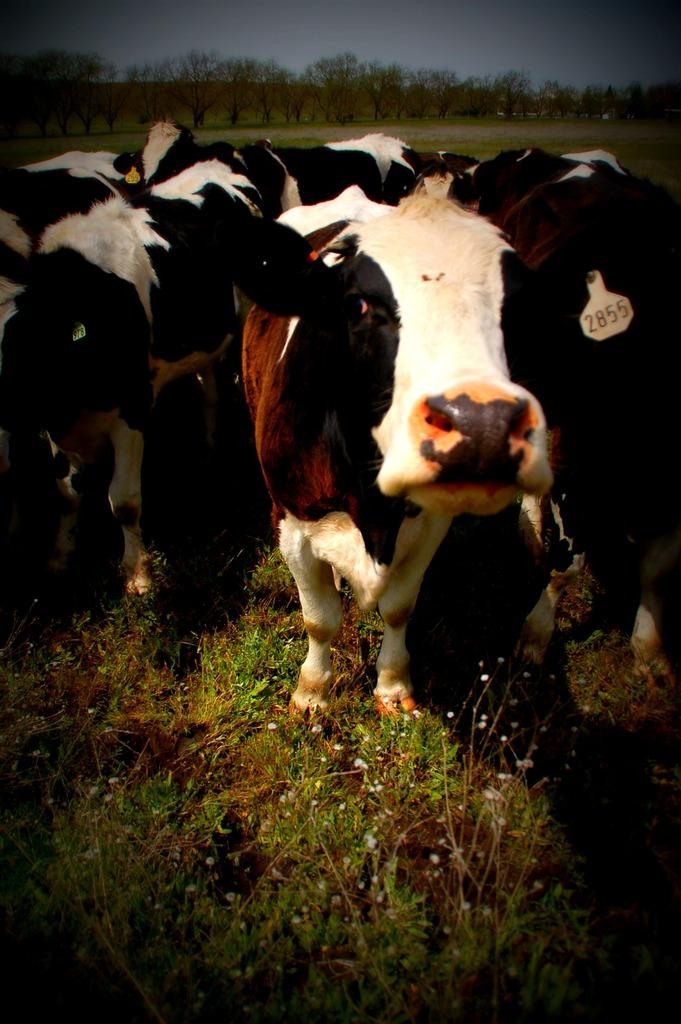What animals are in the center of the image? There are cows in the center of the image. What type of vegetation is at the bottom of the image? There is grass at the bottom of the image. What can be seen in the background of the image? There are trees and the sky visible in the background of the image. What type of action is the goat performing in the image? There is no goat present in the image, so it is not possible to answer that question. 